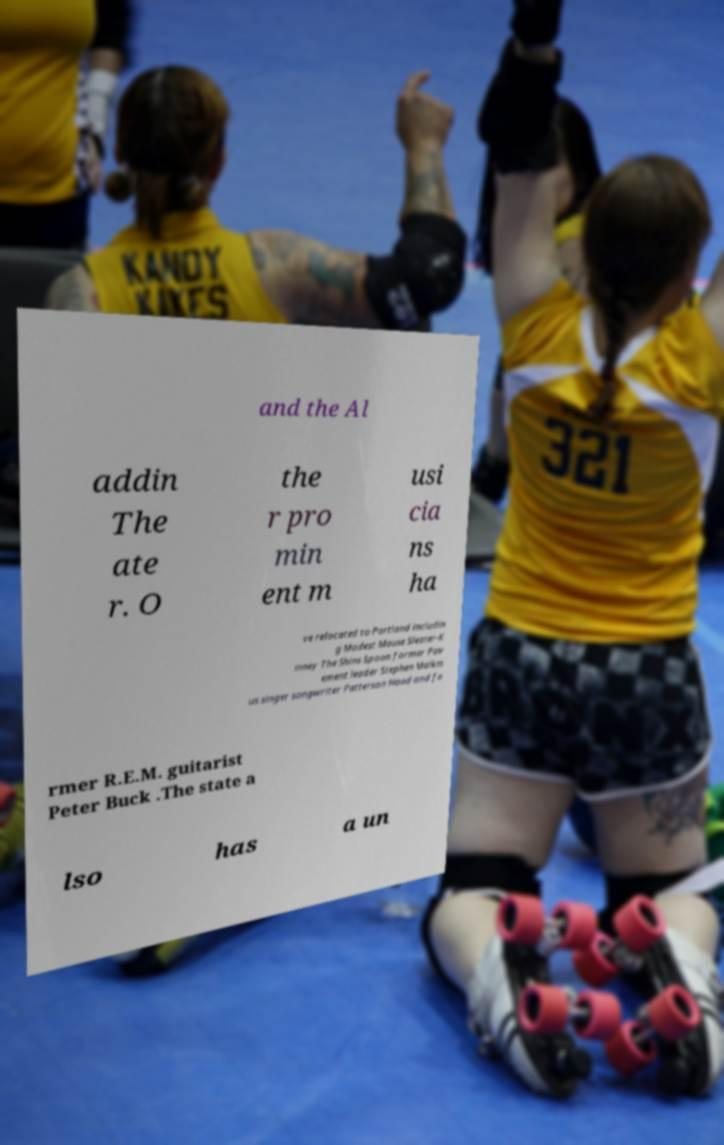Can you accurately transcribe the text from the provided image for me? and the Al addin The ate r. O the r pro min ent m usi cia ns ha ve relocated to Portland includin g Modest Mouse Sleater-K inney The Shins Spoon former Pav ement leader Stephen Malkm us singer songwriter Patterson Hood and fo rmer R.E.M. guitarist Peter Buck .The state a lso has a un 